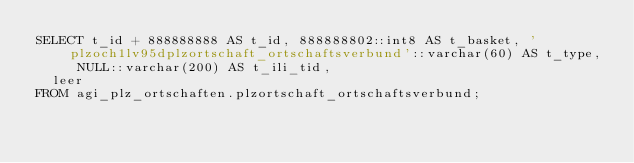Convert code to text. <code><loc_0><loc_0><loc_500><loc_500><_SQL_>SELECT t_id + 888888888 AS t_id, 888888802::int8 AS t_basket, 'plzoch1lv95dplzortschaft_ortschaftsverbund'::varchar(60) AS t_type, NULL::varchar(200) AS t_ili_tid,
  leer
FROM agi_plz_ortschaften.plzortschaft_ortschaftsverbund;
</code> 